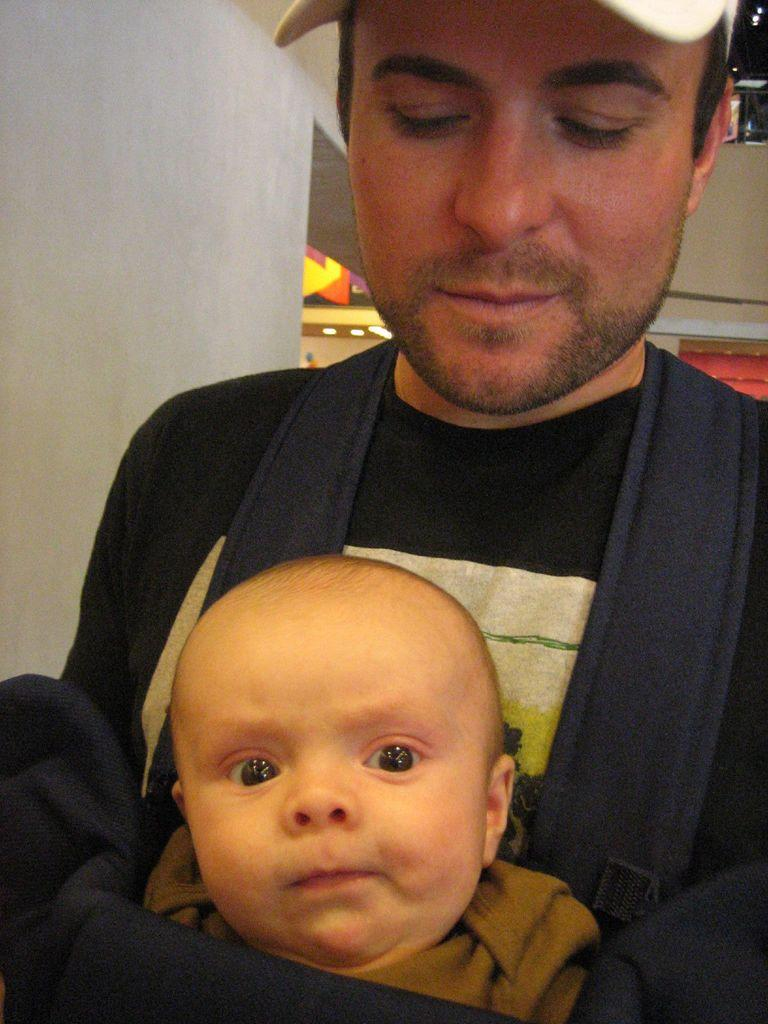What is the main subject of the image? There is a person in the image. What is the person doing in the image? The person is carrying a baby in a kangaroo bag. What is the person's facial expression in the image? The person is smiling. What type of clothing is the person wearing in the image? The person is wearing a cap. What type of honey is being used to plot a receipt in the image? There is no honey, plotting, or receipt present in the image. 